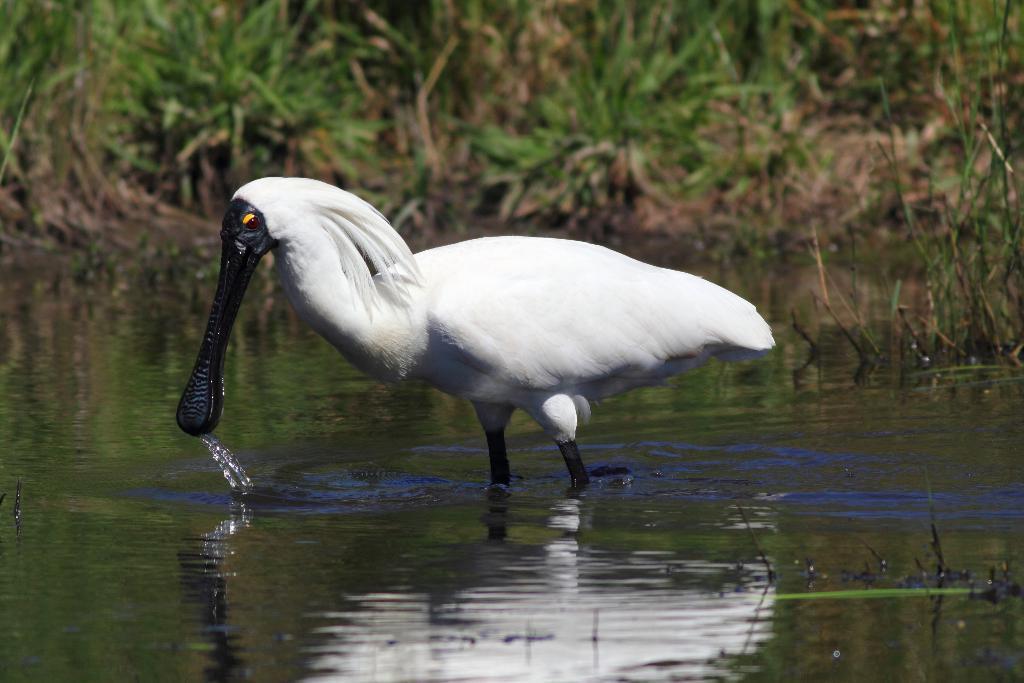Describe this image in one or two sentences. In the picture I can see a white color bird in the water. In the background I can see planets and the grass. The background of the image is blurred. 